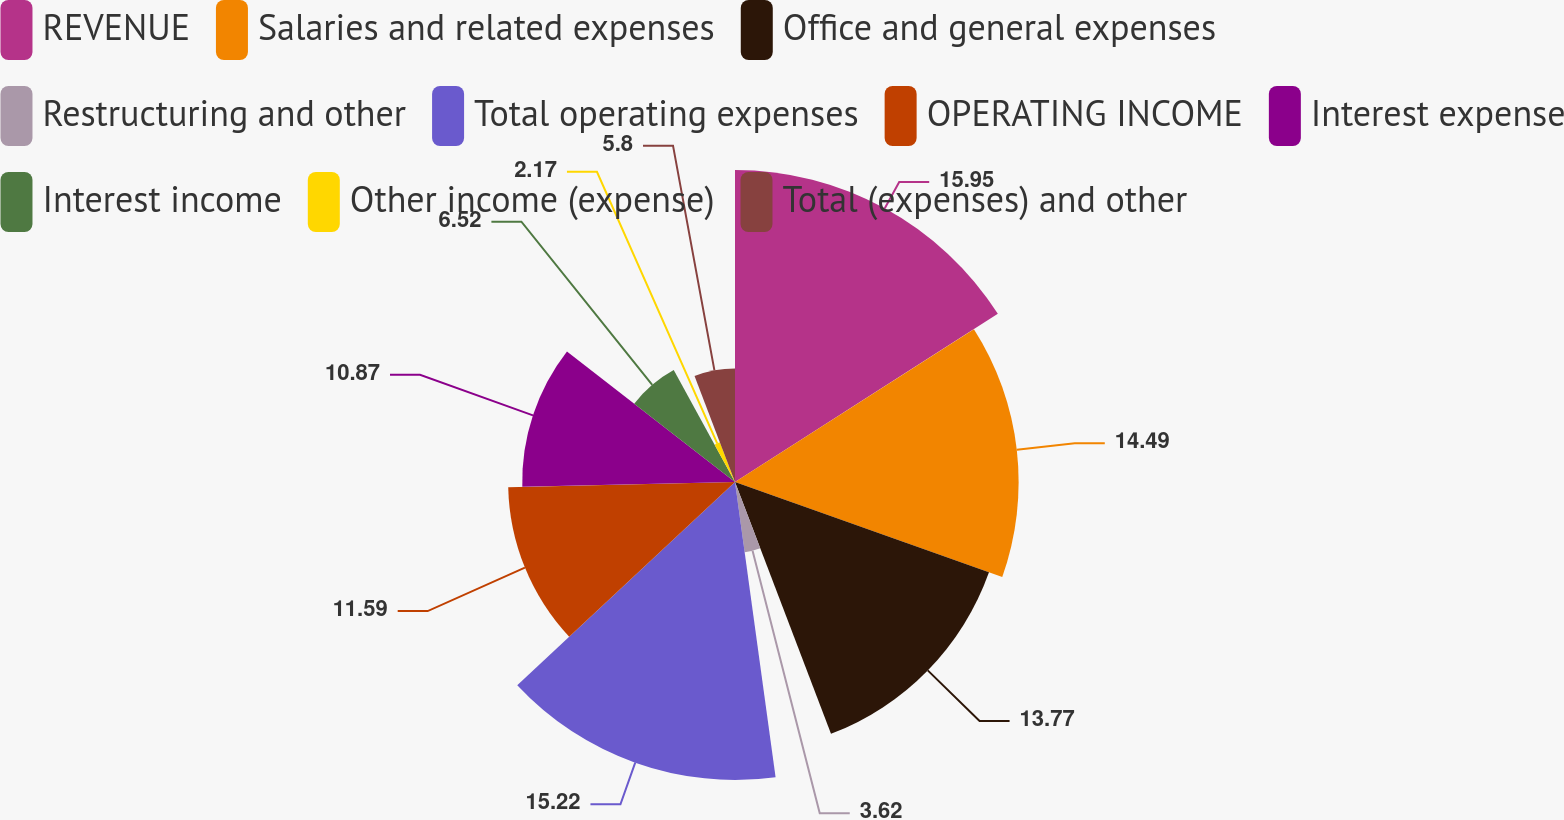Convert chart. <chart><loc_0><loc_0><loc_500><loc_500><pie_chart><fcel>REVENUE<fcel>Salaries and related expenses<fcel>Office and general expenses<fcel>Restructuring and other<fcel>Total operating expenses<fcel>OPERATING INCOME<fcel>Interest expense<fcel>Interest income<fcel>Other income (expense)<fcel>Total (expenses) and other<nl><fcel>15.94%<fcel>14.49%<fcel>13.77%<fcel>3.62%<fcel>15.22%<fcel>11.59%<fcel>10.87%<fcel>6.52%<fcel>2.17%<fcel>5.8%<nl></chart> 